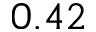<formula> <loc_0><loc_0><loc_500><loc_500>0 . 4 2</formula> 